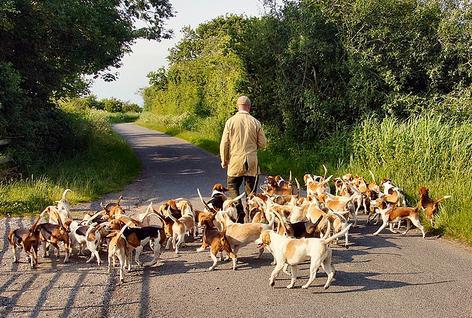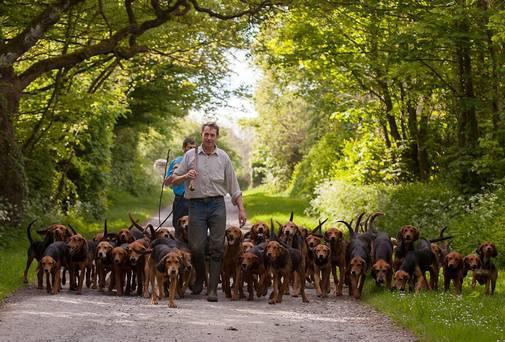The first image is the image on the left, the second image is the image on the right. Assess this claim about the two images: "There are exactly two people in the image on the right.". Correct or not? Answer yes or no. Yes. 